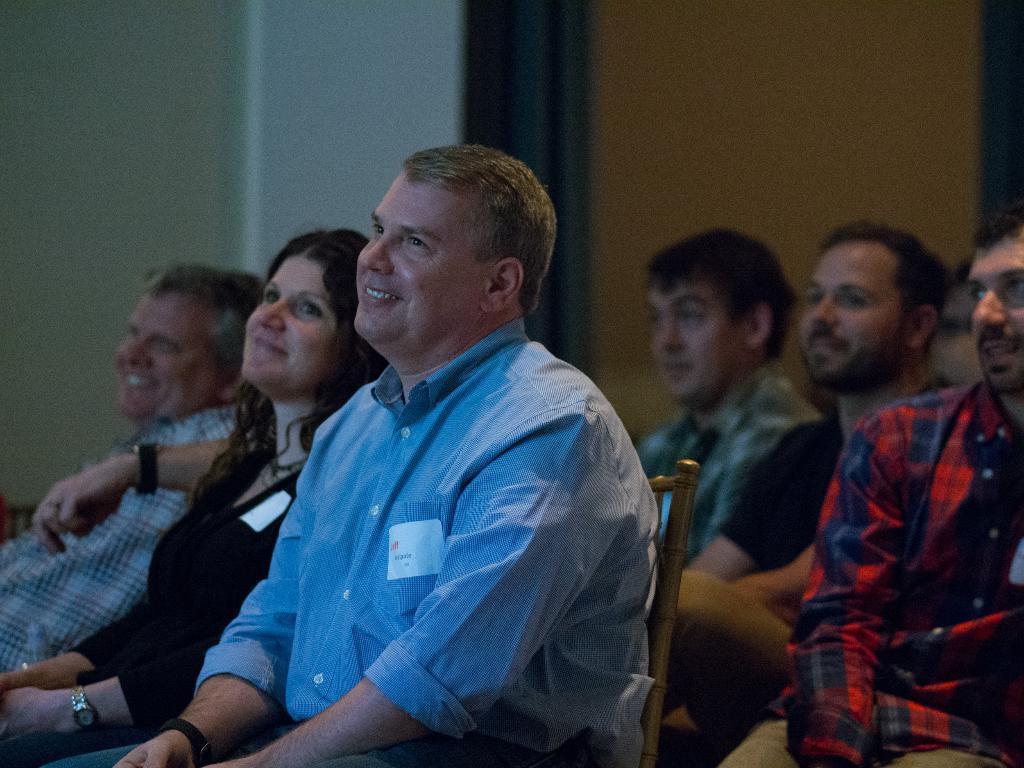Describe this image in one or two sentences. In this picture there are people sitting in chairs. In the foreground there is a man in blue shirt. In the background there is wall. 